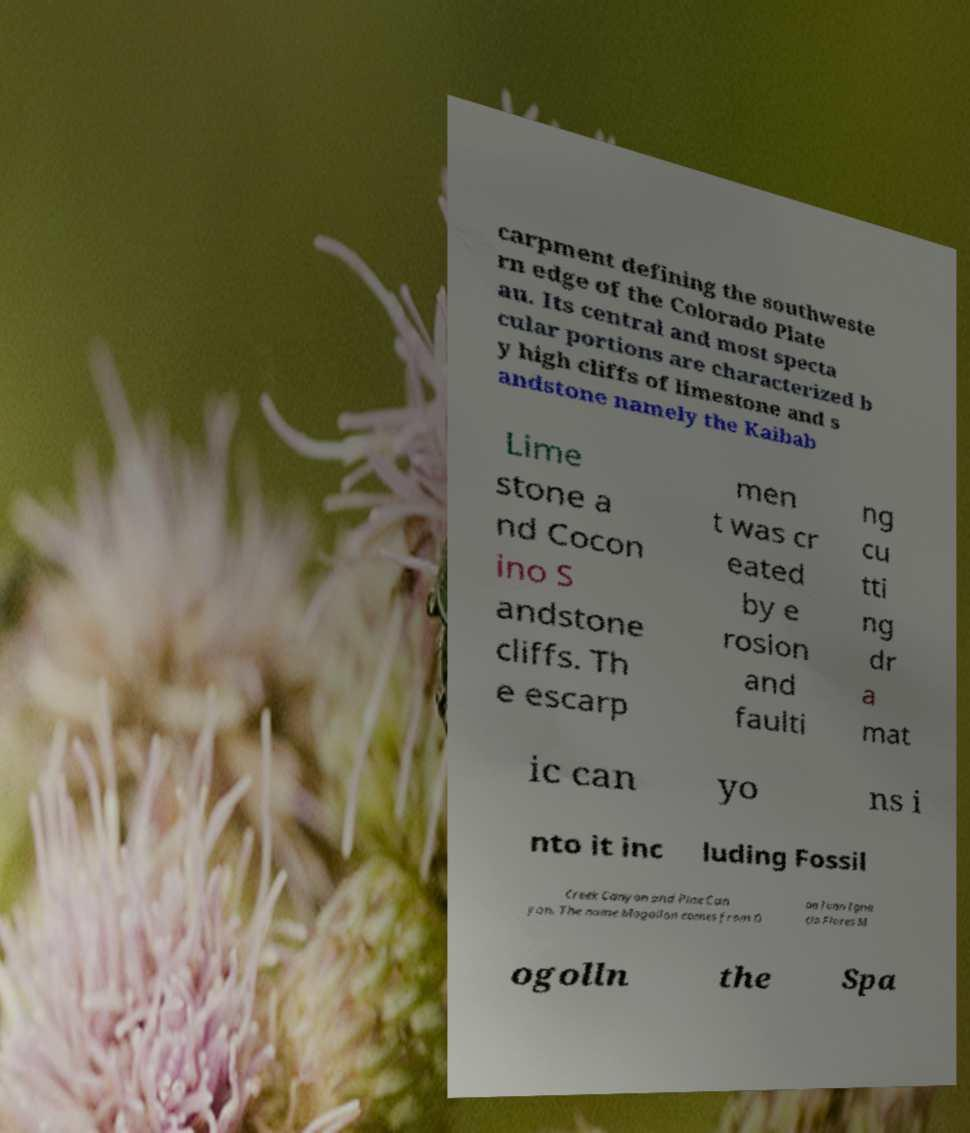Please identify and transcribe the text found in this image. carpment defining the southweste rn edge of the Colorado Plate au. Its central and most specta cular portions are characterized b y high cliffs of limestone and s andstone namely the Kaibab Lime stone a nd Cocon ino S andstone cliffs. Th e escarp men t was cr eated by e rosion and faulti ng cu tti ng dr a mat ic can yo ns i nto it inc luding Fossil Creek Canyon and Pine Can yon. The name Mogollon comes from D on Juan Igna cio Flores M ogolln the Spa 